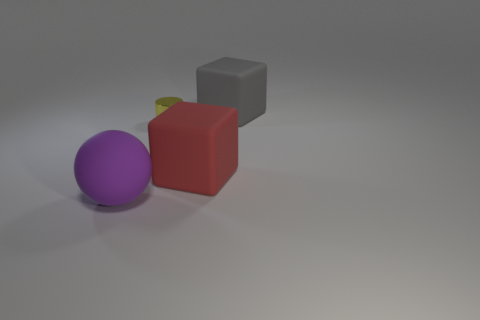Add 2 yellow cylinders. How many objects exist? 6 Subtract 0 green cylinders. How many objects are left? 4 Subtract all cylinders. How many objects are left? 3 Subtract 1 balls. How many balls are left? 0 Subtract all blue cylinders. Subtract all blue cubes. How many cylinders are left? 1 Subtract all cyan cylinders. How many gray balls are left? 0 Subtract all tiny cyan shiny spheres. Subtract all large red matte things. How many objects are left? 3 Add 3 purple objects. How many purple objects are left? 4 Add 2 gray things. How many gray things exist? 3 